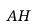Convert formula to latex. <formula><loc_0><loc_0><loc_500><loc_500>A H</formula> 